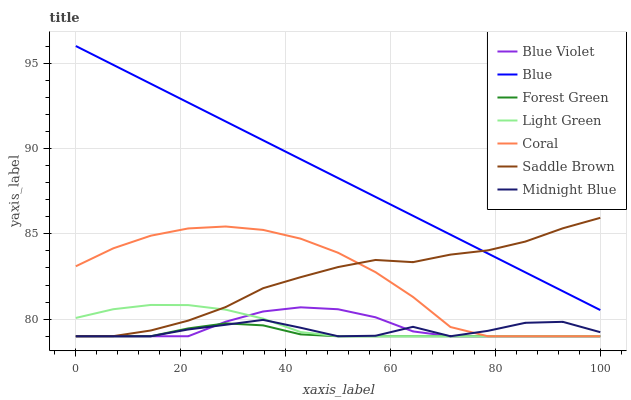Does Forest Green have the minimum area under the curve?
Answer yes or no. Yes. Does Blue have the maximum area under the curve?
Answer yes or no. Yes. Does Midnight Blue have the minimum area under the curve?
Answer yes or no. No. Does Midnight Blue have the maximum area under the curve?
Answer yes or no. No. Is Blue the smoothest?
Answer yes or no. Yes. Is Midnight Blue the roughest?
Answer yes or no. Yes. Is Coral the smoothest?
Answer yes or no. No. Is Coral the roughest?
Answer yes or no. No. Does Midnight Blue have the highest value?
Answer yes or no. No. Is Blue Violet less than Blue?
Answer yes or no. Yes. Is Blue greater than Blue Violet?
Answer yes or no. Yes. Does Blue Violet intersect Blue?
Answer yes or no. No. 